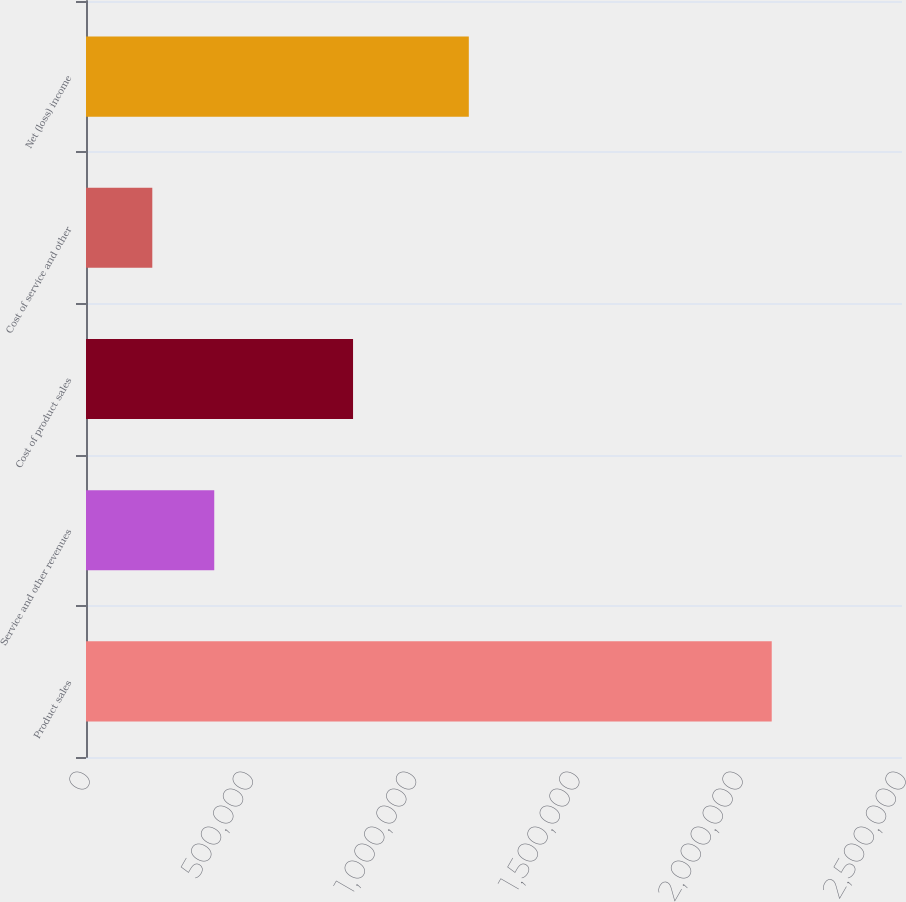Convert chart to OTSL. <chart><loc_0><loc_0><loc_500><loc_500><bar_chart><fcel>Product sales<fcel>Service and other revenues<fcel>Cost of product sales<fcel>Cost of service and other<fcel>Net (loss) income<nl><fcel>2.10089e+06<fcel>392899<fcel>818160<fcel>203122<fcel>1.17284e+06<nl></chart> 